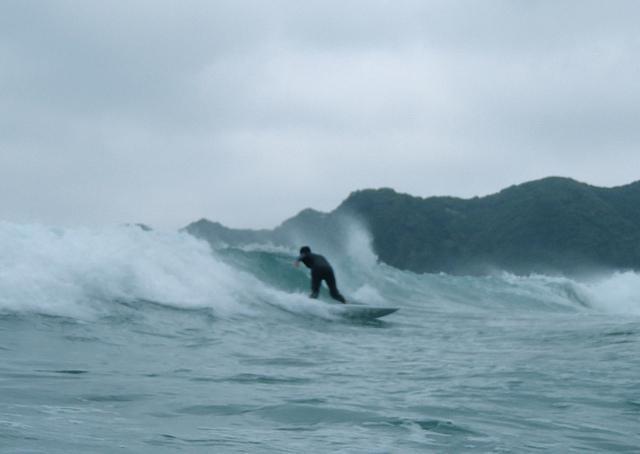How many feet does the man have on the surfboard?
Give a very brief answer. 2. How many dark brown horses are in the photo?
Give a very brief answer. 0. 